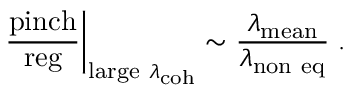<formula> <loc_0><loc_0><loc_500><loc_500>{ \frac { p i n c h } { r e g } } \right | _ { l \arg e \ \lambda _ { c o h } } \sim { \frac { \lambda _ { m e a n } } { \lambda _ { n o n \ e q } } } \, .</formula> 